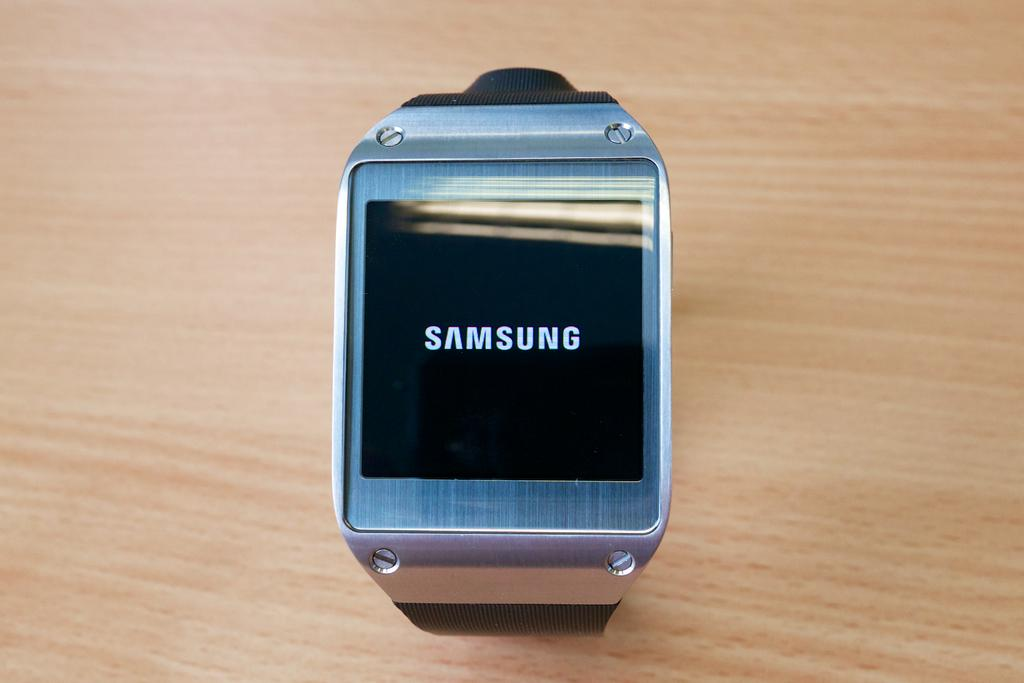What electronic device is visible in the image? There is a smart watch in the image. Where is the smart watch located? The smart watch is on a wooden table. What type of jail is visible in the image? There is no jail present in the image; it features a smart watch on a wooden table. How many hens are visible in the image? There are no hens present in the image. 